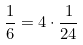Convert formula to latex. <formula><loc_0><loc_0><loc_500><loc_500>\frac { 1 } { 6 } = 4 \cdot \frac { 1 } { 2 4 }</formula> 